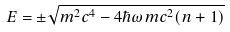Convert formula to latex. <formula><loc_0><loc_0><loc_500><loc_500>E = \pm \sqrt { m ^ { 2 } c ^ { 4 } - 4 \hbar { \omega } m c ^ { 2 } ( n + 1 ) }</formula> 